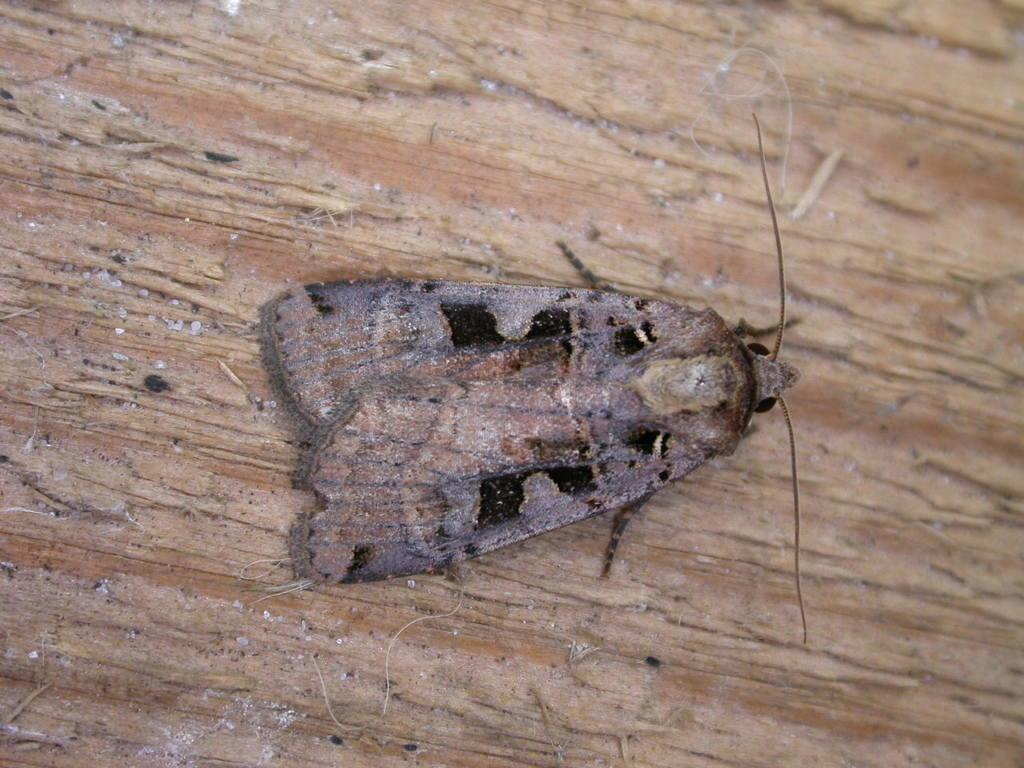What type of table is in the image? There is a wood table in the image. What else can be seen on the table? An insect is in the image. Can you describe the insect's appearance? The insect is brown in color. What type of nerve is visible in the image? There is no nerve visible in the image; it features a wood table and an insect. What type of slave is depicted in the image? There is no slave depicted in the image; it features a wood table and an insect. 